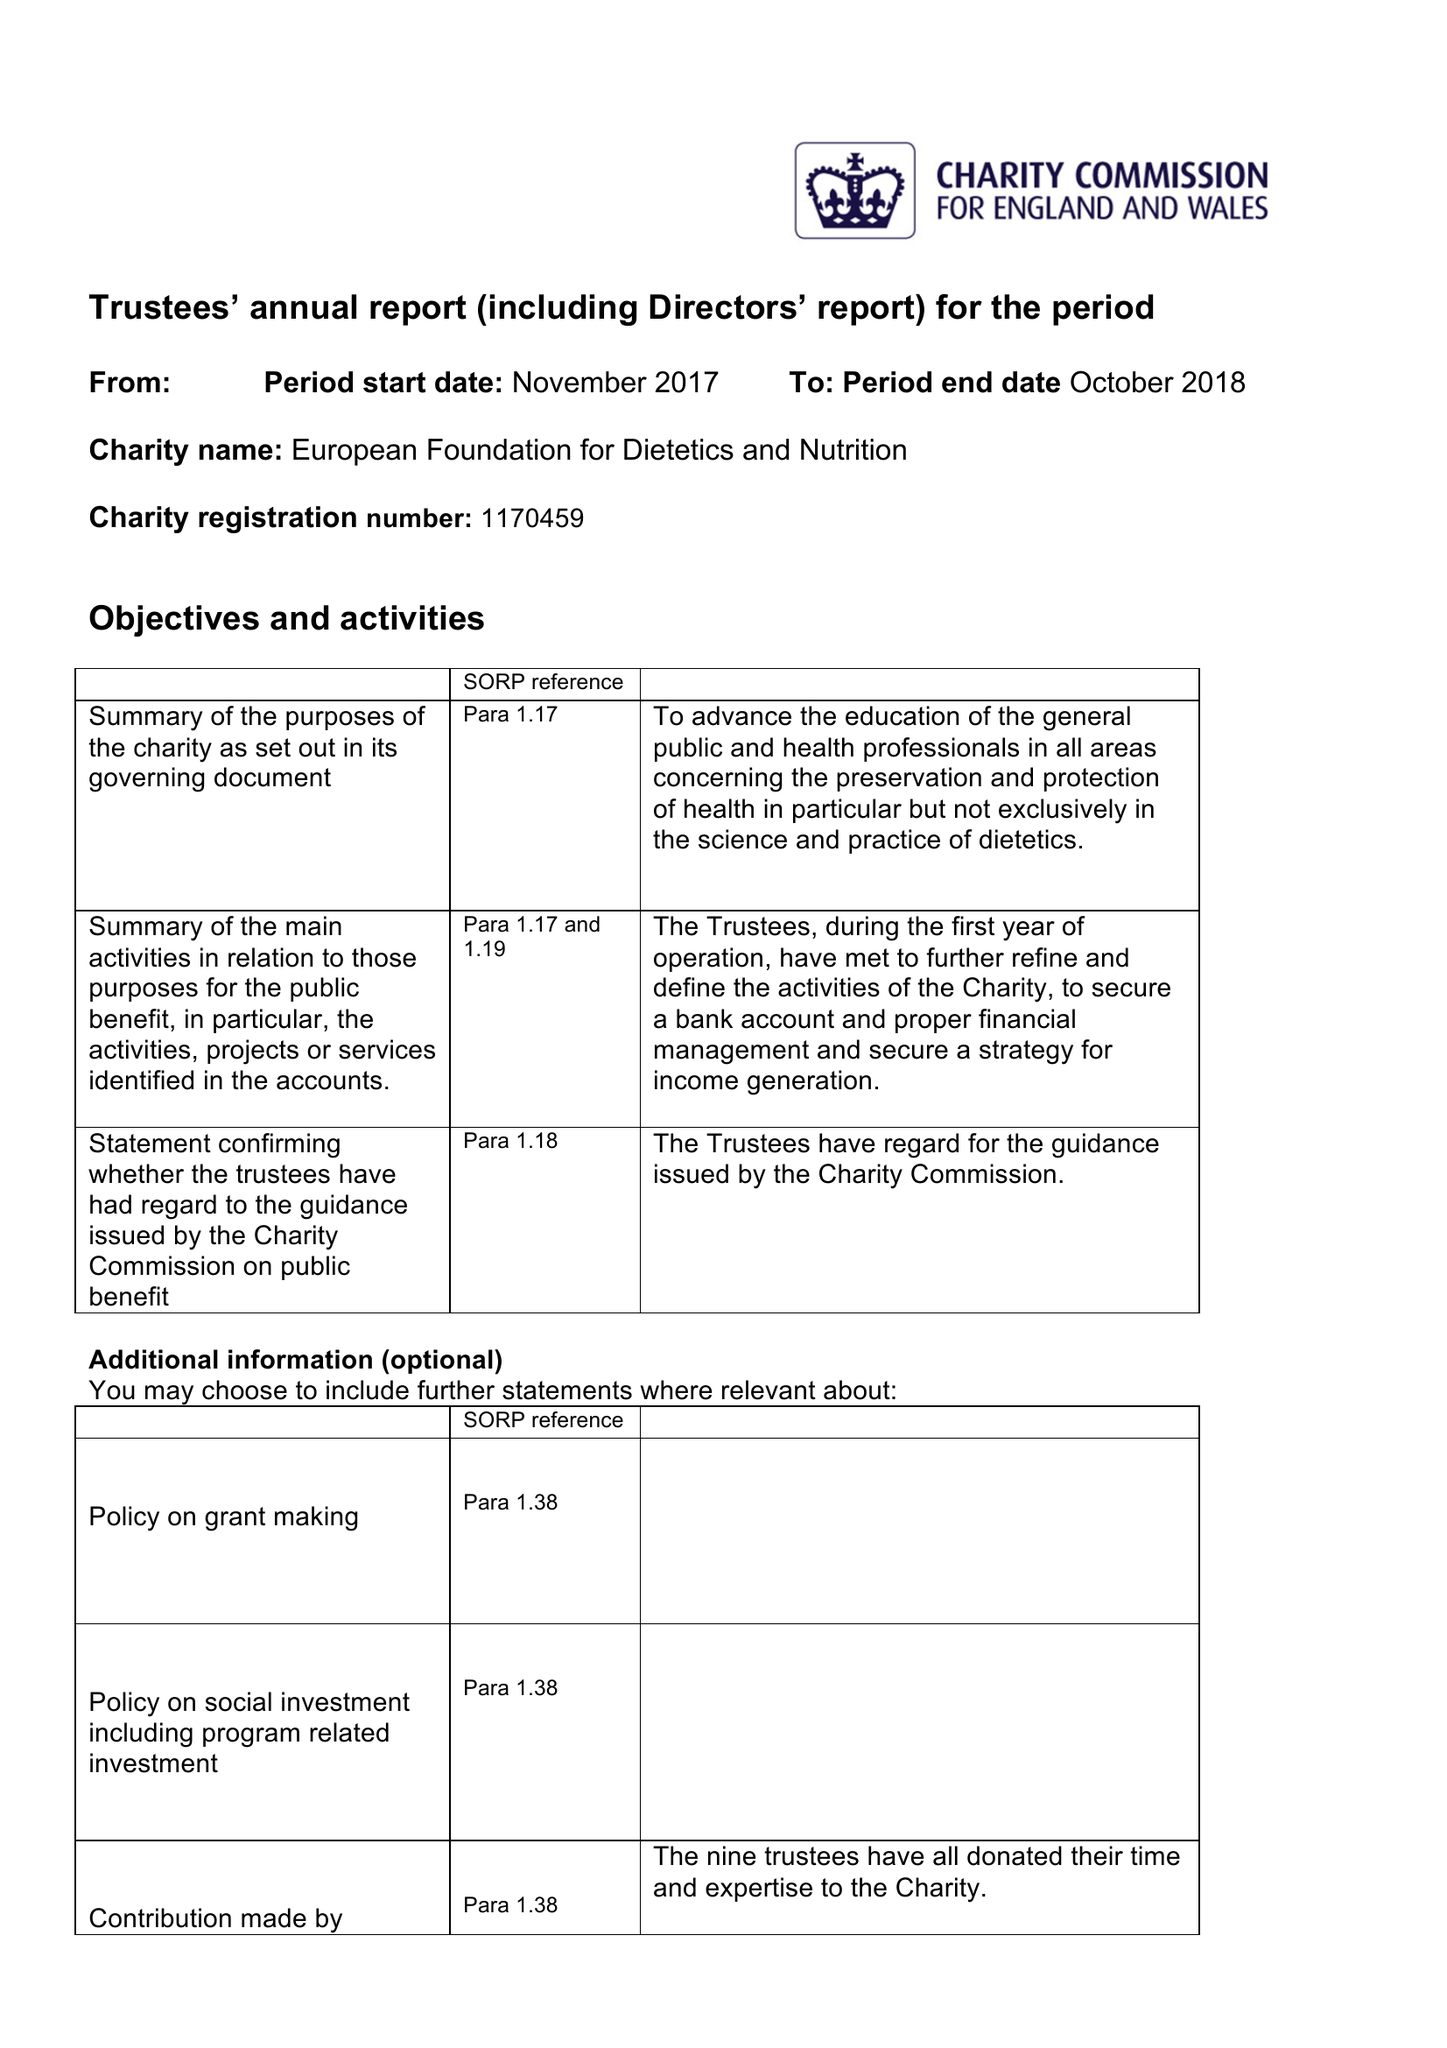What is the value for the report_date?
Answer the question using a single word or phrase. 2018-02-28 